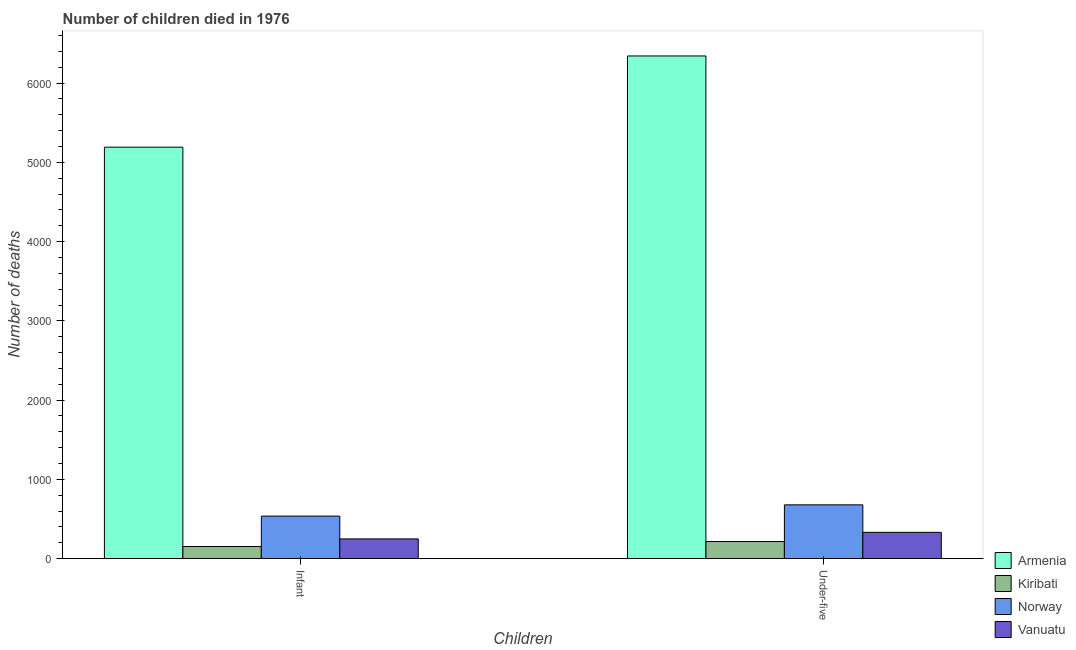Are the number of bars per tick equal to the number of legend labels?
Offer a terse response. Yes. Are the number of bars on each tick of the X-axis equal?
Ensure brevity in your answer.  Yes. How many bars are there on the 2nd tick from the right?
Give a very brief answer. 4. What is the label of the 1st group of bars from the left?
Ensure brevity in your answer.  Infant. What is the number of under-five deaths in Norway?
Ensure brevity in your answer.  678. Across all countries, what is the maximum number of under-five deaths?
Keep it short and to the point. 6343. Across all countries, what is the minimum number of infant deaths?
Provide a short and direct response. 152. In which country was the number of infant deaths maximum?
Your answer should be compact. Armenia. In which country was the number of infant deaths minimum?
Your answer should be very brief. Kiribati. What is the total number of under-five deaths in the graph?
Your response must be concise. 7567. What is the difference between the number of infant deaths in Armenia and that in Vanuatu?
Keep it short and to the point. 4944. What is the difference between the number of infant deaths in Norway and the number of under-five deaths in Kiribati?
Offer a very short reply. 321. What is the average number of infant deaths per country?
Your answer should be very brief. 1532. What is the difference between the number of under-five deaths and number of infant deaths in Vanuatu?
Give a very brief answer. 83. What is the ratio of the number of under-five deaths in Kiribati to that in Norway?
Give a very brief answer. 0.32. Is the number of infant deaths in Kiribati less than that in Vanuatu?
Your answer should be very brief. Yes. What does the 2nd bar from the left in Infant represents?
Provide a succinct answer. Kiribati. What does the 4th bar from the right in Infant represents?
Make the answer very short. Armenia. Are all the bars in the graph horizontal?
Ensure brevity in your answer.  No. How many countries are there in the graph?
Offer a terse response. 4. Where does the legend appear in the graph?
Your response must be concise. Bottom right. How are the legend labels stacked?
Your answer should be compact. Vertical. What is the title of the graph?
Make the answer very short. Number of children died in 1976. Does "Russian Federation" appear as one of the legend labels in the graph?
Make the answer very short. No. What is the label or title of the X-axis?
Make the answer very short. Children. What is the label or title of the Y-axis?
Your response must be concise. Number of deaths. What is the Number of deaths of Armenia in Infant?
Provide a succinct answer. 5192. What is the Number of deaths in Kiribati in Infant?
Make the answer very short. 152. What is the Number of deaths of Norway in Infant?
Offer a terse response. 536. What is the Number of deaths in Vanuatu in Infant?
Your response must be concise. 248. What is the Number of deaths in Armenia in Under-five?
Your response must be concise. 6343. What is the Number of deaths in Kiribati in Under-five?
Make the answer very short. 215. What is the Number of deaths in Norway in Under-five?
Keep it short and to the point. 678. What is the Number of deaths of Vanuatu in Under-five?
Keep it short and to the point. 331. Across all Children, what is the maximum Number of deaths in Armenia?
Your answer should be very brief. 6343. Across all Children, what is the maximum Number of deaths of Kiribati?
Offer a very short reply. 215. Across all Children, what is the maximum Number of deaths of Norway?
Give a very brief answer. 678. Across all Children, what is the maximum Number of deaths in Vanuatu?
Keep it short and to the point. 331. Across all Children, what is the minimum Number of deaths in Armenia?
Ensure brevity in your answer.  5192. Across all Children, what is the minimum Number of deaths in Kiribati?
Offer a very short reply. 152. Across all Children, what is the minimum Number of deaths in Norway?
Your response must be concise. 536. Across all Children, what is the minimum Number of deaths of Vanuatu?
Ensure brevity in your answer.  248. What is the total Number of deaths in Armenia in the graph?
Your answer should be compact. 1.15e+04. What is the total Number of deaths in Kiribati in the graph?
Ensure brevity in your answer.  367. What is the total Number of deaths of Norway in the graph?
Make the answer very short. 1214. What is the total Number of deaths of Vanuatu in the graph?
Provide a succinct answer. 579. What is the difference between the Number of deaths in Armenia in Infant and that in Under-five?
Keep it short and to the point. -1151. What is the difference between the Number of deaths of Kiribati in Infant and that in Under-five?
Offer a very short reply. -63. What is the difference between the Number of deaths of Norway in Infant and that in Under-five?
Your response must be concise. -142. What is the difference between the Number of deaths of Vanuatu in Infant and that in Under-five?
Make the answer very short. -83. What is the difference between the Number of deaths in Armenia in Infant and the Number of deaths in Kiribati in Under-five?
Your answer should be very brief. 4977. What is the difference between the Number of deaths in Armenia in Infant and the Number of deaths in Norway in Under-five?
Provide a short and direct response. 4514. What is the difference between the Number of deaths in Armenia in Infant and the Number of deaths in Vanuatu in Under-five?
Ensure brevity in your answer.  4861. What is the difference between the Number of deaths of Kiribati in Infant and the Number of deaths of Norway in Under-five?
Give a very brief answer. -526. What is the difference between the Number of deaths in Kiribati in Infant and the Number of deaths in Vanuatu in Under-five?
Make the answer very short. -179. What is the difference between the Number of deaths of Norway in Infant and the Number of deaths of Vanuatu in Under-five?
Your answer should be very brief. 205. What is the average Number of deaths in Armenia per Children?
Provide a succinct answer. 5767.5. What is the average Number of deaths of Kiribati per Children?
Provide a short and direct response. 183.5. What is the average Number of deaths in Norway per Children?
Keep it short and to the point. 607. What is the average Number of deaths of Vanuatu per Children?
Provide a short and direct response. 289.5. What is the difference between the Number of deaths of Armenia and Number of deaths of Kiribati in Infant?
Offer a terse response. 5040. What is the difference between the Number of deaths in Armenia and Number of deaths in Norway in Infant?
Make the answer very short. 4656. What is the difference between the Number of deaths in Armenia and Number of deaths in Vanuatu in Infant?
Your response must be concise. 4944. What is the difference between the Number of deaths in Kiribati and Number of deaths in Norway in Infant?
Keep it short and to the point. -384. What is the difference between the Number of deaths of Kiribati and Number of deaths of Vanuatu in Infant?
Your response must be concise. -96. What is the difference between the Number of deaths in Norway and Number of deaths in Vanuatu in Infant?
Offer a terse response. 288. What is the difference between the Number of deaths of Armenia and Number of deaths of Kiribati in Under-five?
Offer a very short reply. 6128. What is the difference between the Number of deaths of Armenia and Number of deaths of Norway in Under-five?
Your answer should be compact. 5665. What is the difference between the Number of deaths in Armenia and Number of deaths in Vanuatu in Under-five?
Provide a short and direct response. 6012. What is the difference between the Number of deaths of Kiribati and Number of deaths of Norway in Under-five?
Make the answer very short. -463. What is the difference between the Number of deaths of Kiribati and Number of deaths of Vanuatu in Under-five?
Offer a terse response. -116. What is the difference between the Number of deaths of Norway and Number of deaths of Vanuatu in Under-five?
Provide a short and direct response. 347. What is the ratio of the Number of deaths of Armenia in Infant to that in Under-five?
Offer a very short reply. 0.82. What is the ratio of the Number of deaths of Kiribati in Infant to that in Under-five?
Your answer should be very brief. 0.71. What is the ratio of the Number of deaths in Norway in Infant to that in Under-five?
Provide a short and direct response. 0.79. What is the ratio of the Number of deaths of Vanuatu in Infant to that in Under-five?
Your answer should be very brief. 0.75. What is the difference between the highest and the second highest Number of deaths in Armenia?
Provide a succinct answer. 1151. What is the difference between the highest and the second highest Number of deaths in Norway?
Your answer should be compact. 142. What is the difference between the highest and the lowest Number of deaths in Armenia?
Offer a terse response. 1151. What is the difference between the highest and the lowest Number of deaths in Norway?
Offer a very short reply. 142. What is the difference between the highest and the lowest Number of deaths of Vanuatu?
Your answer should be very brief. 83. 